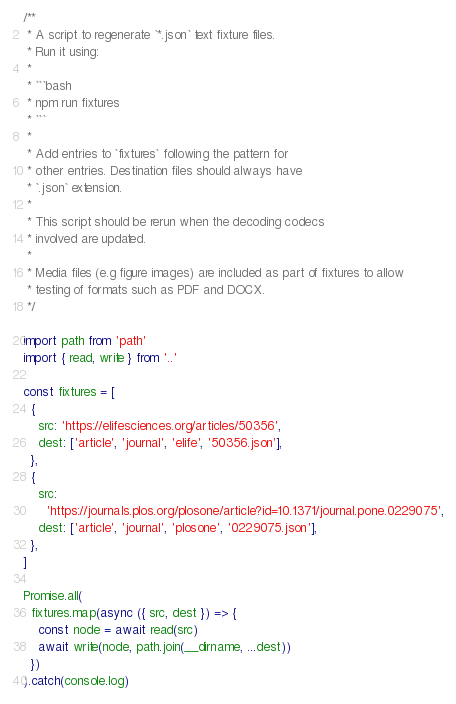Convert code to text. <code><loc_0><loc_0><loc_500><loc_500><_TypeScript_>/**
 * A script to regenerate `*.json` text fixture files.
 * Run it using:
 *
 * ```bash
 * npm run fixtures
 * ```
 *
 * Add entries to `fixtures` following the pattern for
 * other entries. Destination files should always have
 * `.json` extension.
 *
 * This script should be rerun when the decoding codecs
 * involved are updated.
 *
 * Media files (e.g figure images) are included as part of fixtures to allow
 * testing of formats such as PDF and DOCX.
 */

import path from 'path'
import { read, write } from '..'

const fixtures = [
  {
    src: 'https://elifesciences.org/articles/50356',
    dest: ['article', 'journal', 'elife', '50356.json'],
  },
  {
    src:
      'https://journals.plos.org/plosone/article?id=10.1371/journal.pone.0229075',
    dest: ['article', 'journal', 'plosone', '0229075.json'],
  },
]

Promise.all(
  fixtures.map(async ({ src, dest }) => {
    const node = await read(src)
    await write(node, path.join(__dirname, ...dest))
  })
).catch(console.log)
</code> 